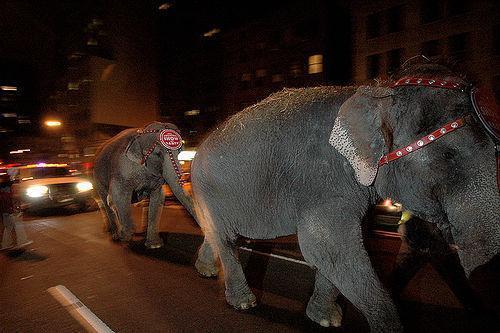How many elephants are in the photo?
Give a very brief answer. 2. How many elephants are there?
Give a very brief answer. 2. 